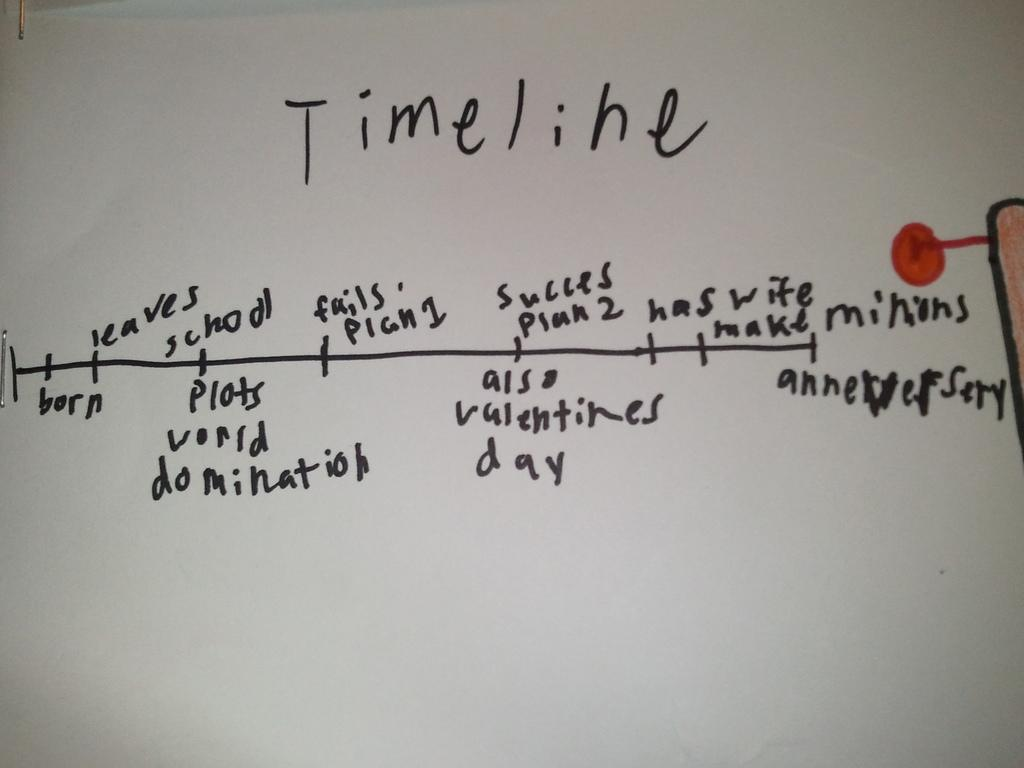Provide a one-sentence caption for the provided image. A handwritten timeline goes from birth to anniversary. 